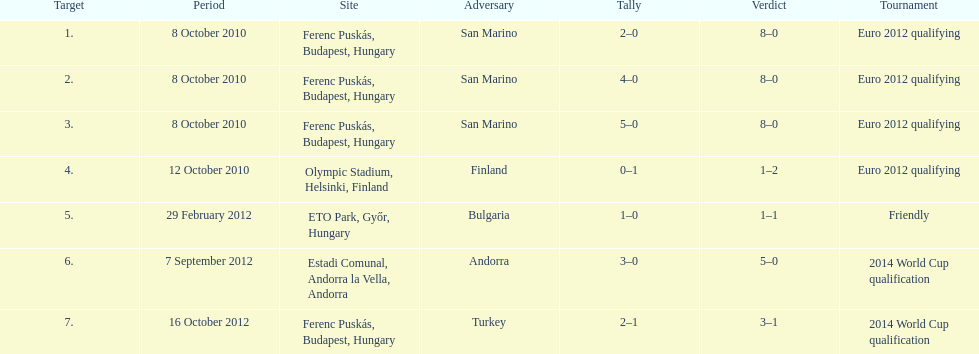How many non-qualifying games did he score in? 1. 